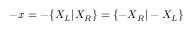<formula> <loc_0><loc_0><loc_500><loc_500>- x = - \{ X _ { L } | X _ { R } \} = \{ - X _ { R } | - X _ { L } \}</formula> 